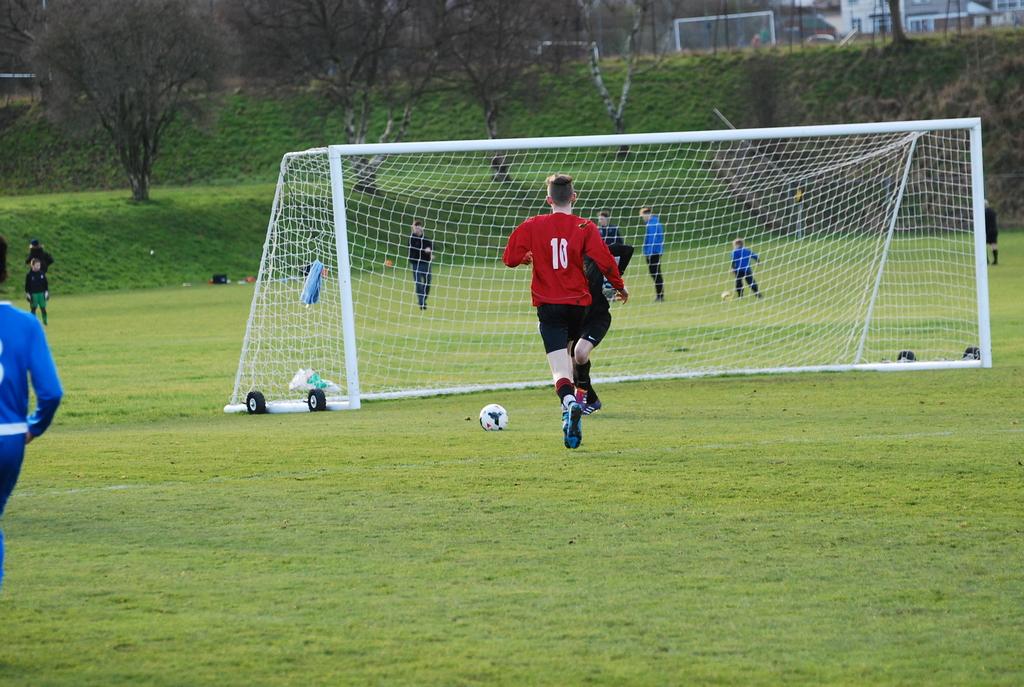Which number is on the jersey?
Make the answer very short. 10. 